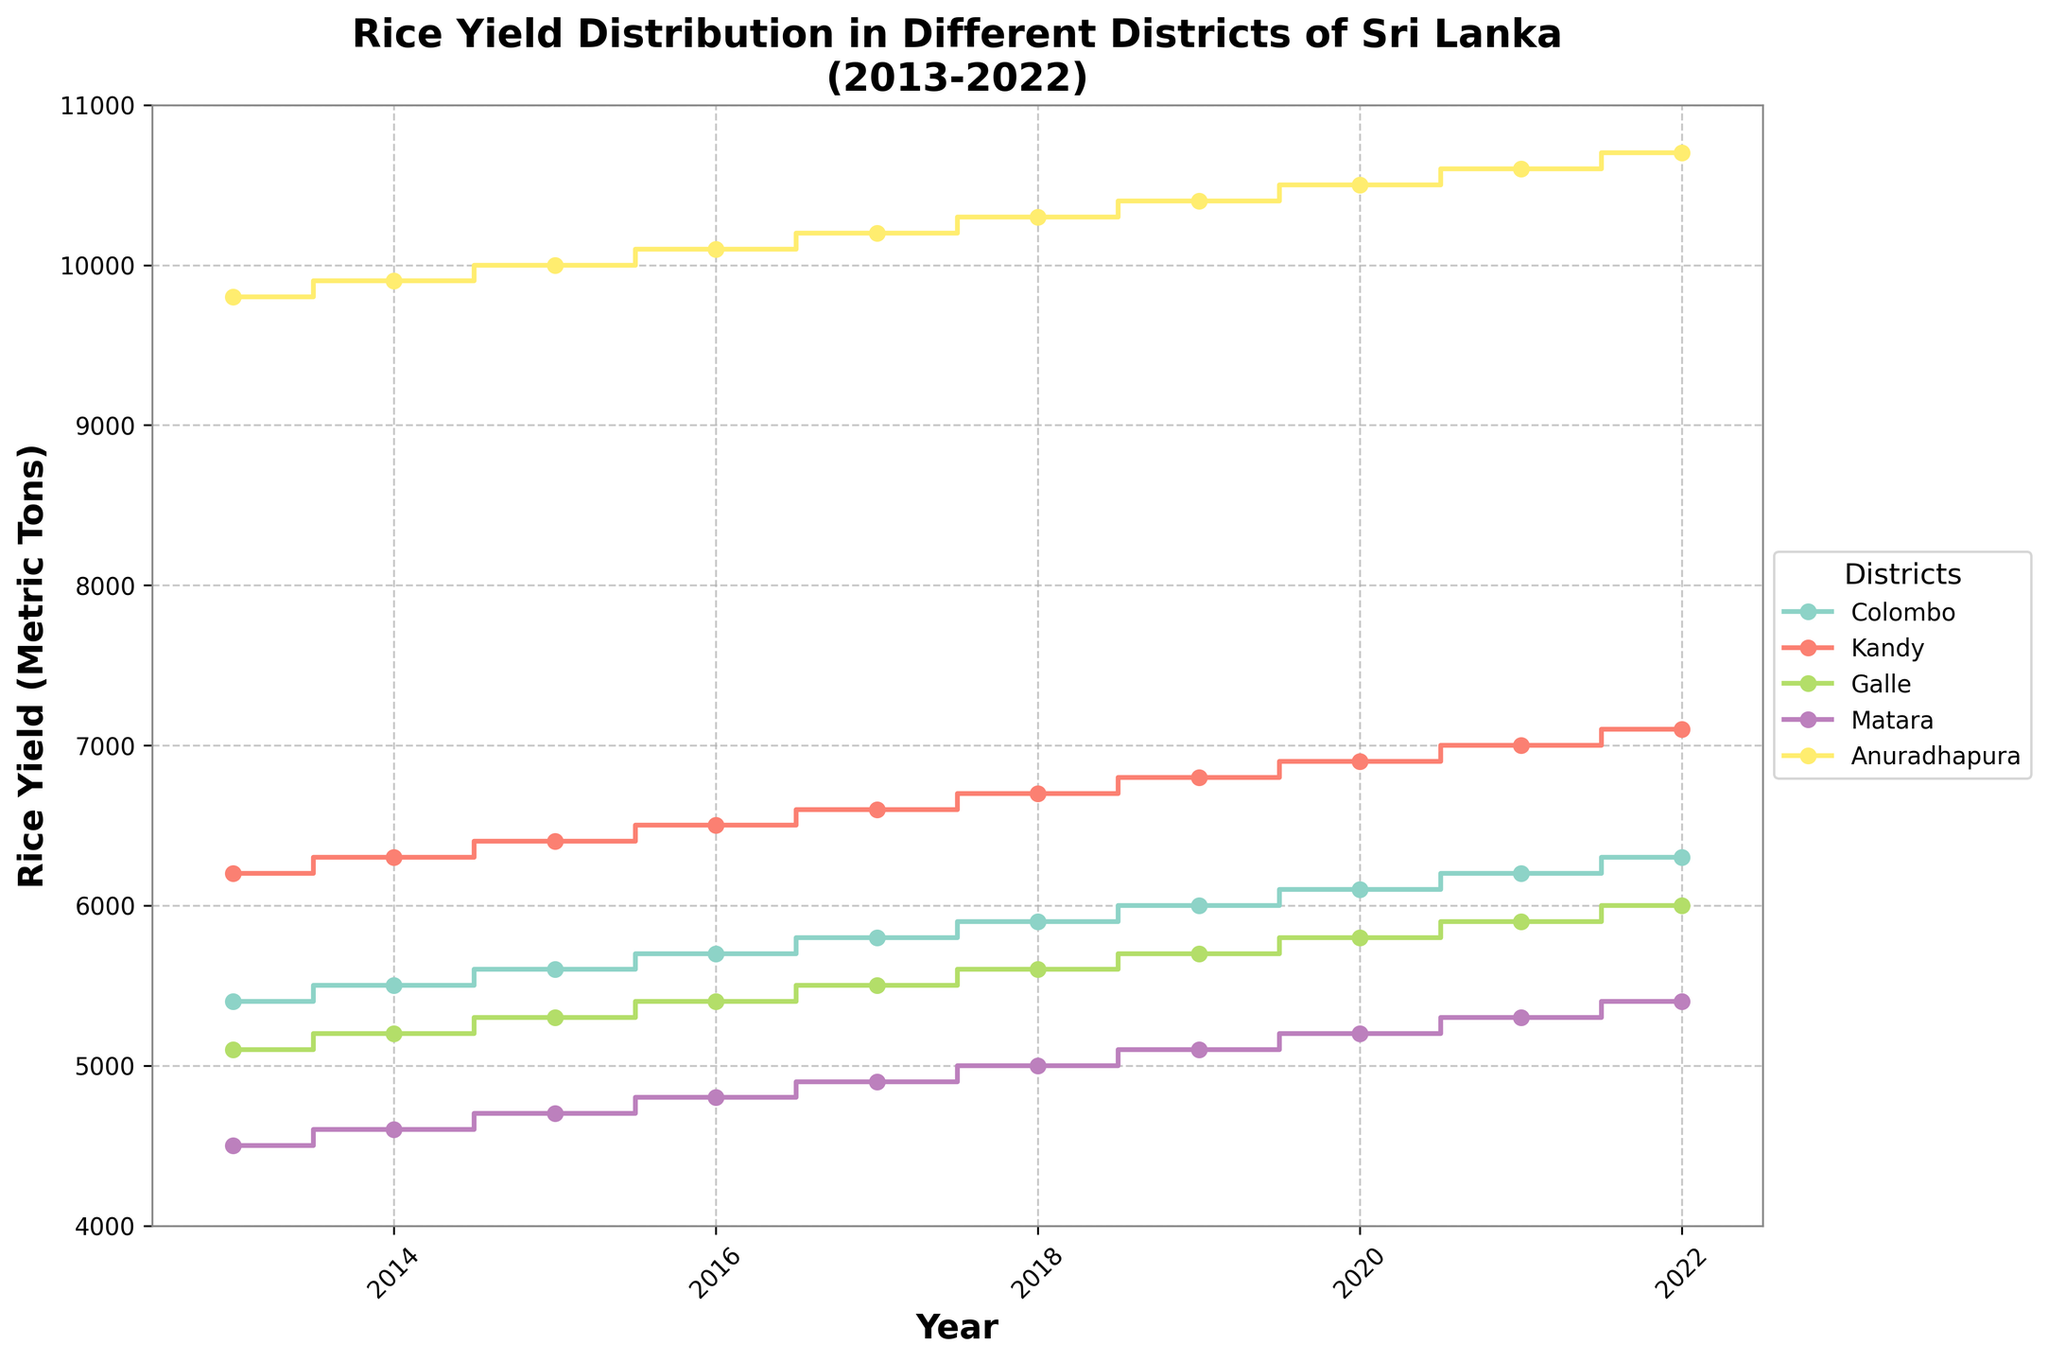How many different districts are represented in the figure? There are five different districts represented in the figure, each with a unique color and labeled in the legend: Colombo, Kandy, Galle, Matara, and Anuradhapura.
Answer: 5 Which district had the highest rice yield in 2022? According to the stair plot, Anuradhapura had the highest rice yield in 2022 with a yield of 10,700 metric tons.
Answer: Anuradhapura By how much did Colombo's rice yield increase from 2013 to 2022? Colombo's rice yield increased from 5,400 metric tons in 2013 to 6,300 metric tons in 2022. The increase is calculated as 6,300 - 5,400 = 900 metric tons.
Answer: 900 metric tons Which year saw the highest rice yield for the Galle district and what was the yield? According to the stair plot, the highest rice yield for Galle district was in 2022, with a yield of 6,000 metric tons.
Answer: 2022, 6,000 metric tons Compare the rice yield trend in Matara with that in Kandy from 2013 to 2022. From 2013 to 2022, the rice yield in Kandy consistently increased from 6,200 to 7,100 metric tons. In contrast, the rice yield in Matara had a slower increase, going from 4,500 to 5,400 metric tons.
Answer: Kandy consistently increased, Matara had a slower increase What is the average rice yield of Colombo over the decade? The rice yields for Colombo from 2013 to 2022 are: 5,400, 5,500, 5,600, 5,700, 5,800, 5,900, 6,000, 6,100, 6,200, 6,300. Adding these yields gives a total of 58,900. Dividing by 10 years, the average is 58,900 / 10 = 5,890 metric tons.
Answer: 5,890 metric tons Which district had the most significant increase in rice yield from 2013 to 2022? Anuradhapura had the most significant increase in rice yield from 2013 to 2022. It increased from 9,800 metric tons in 2013 to 10,700 metric tons in 2022, a total increase of 900 metric tons.
Answer: Anuradhapura In what year did Kandy's rice yield surpass 7,000 metric tons for the first time? According to the stair plot, Kandy's rice yield surpassed 7,000 metric tons for the first time in the year 2021.
Answer: 2021 What is the general trend of rice yield in the district of Kandy? The general trend of rice yield in the district of Kandy is an upward trend, as the yields have gradually increased from the year 2013 to 2022.
Answer: Upward trend Are there any years when the rice yields for all districts decreased or did not increase compared to the previous year? According to the plot, there are no years where the rice yields for all districts decreased or did not increase compared to the previous year. Every year, at least one district's rice yield increased.
Answer: No 